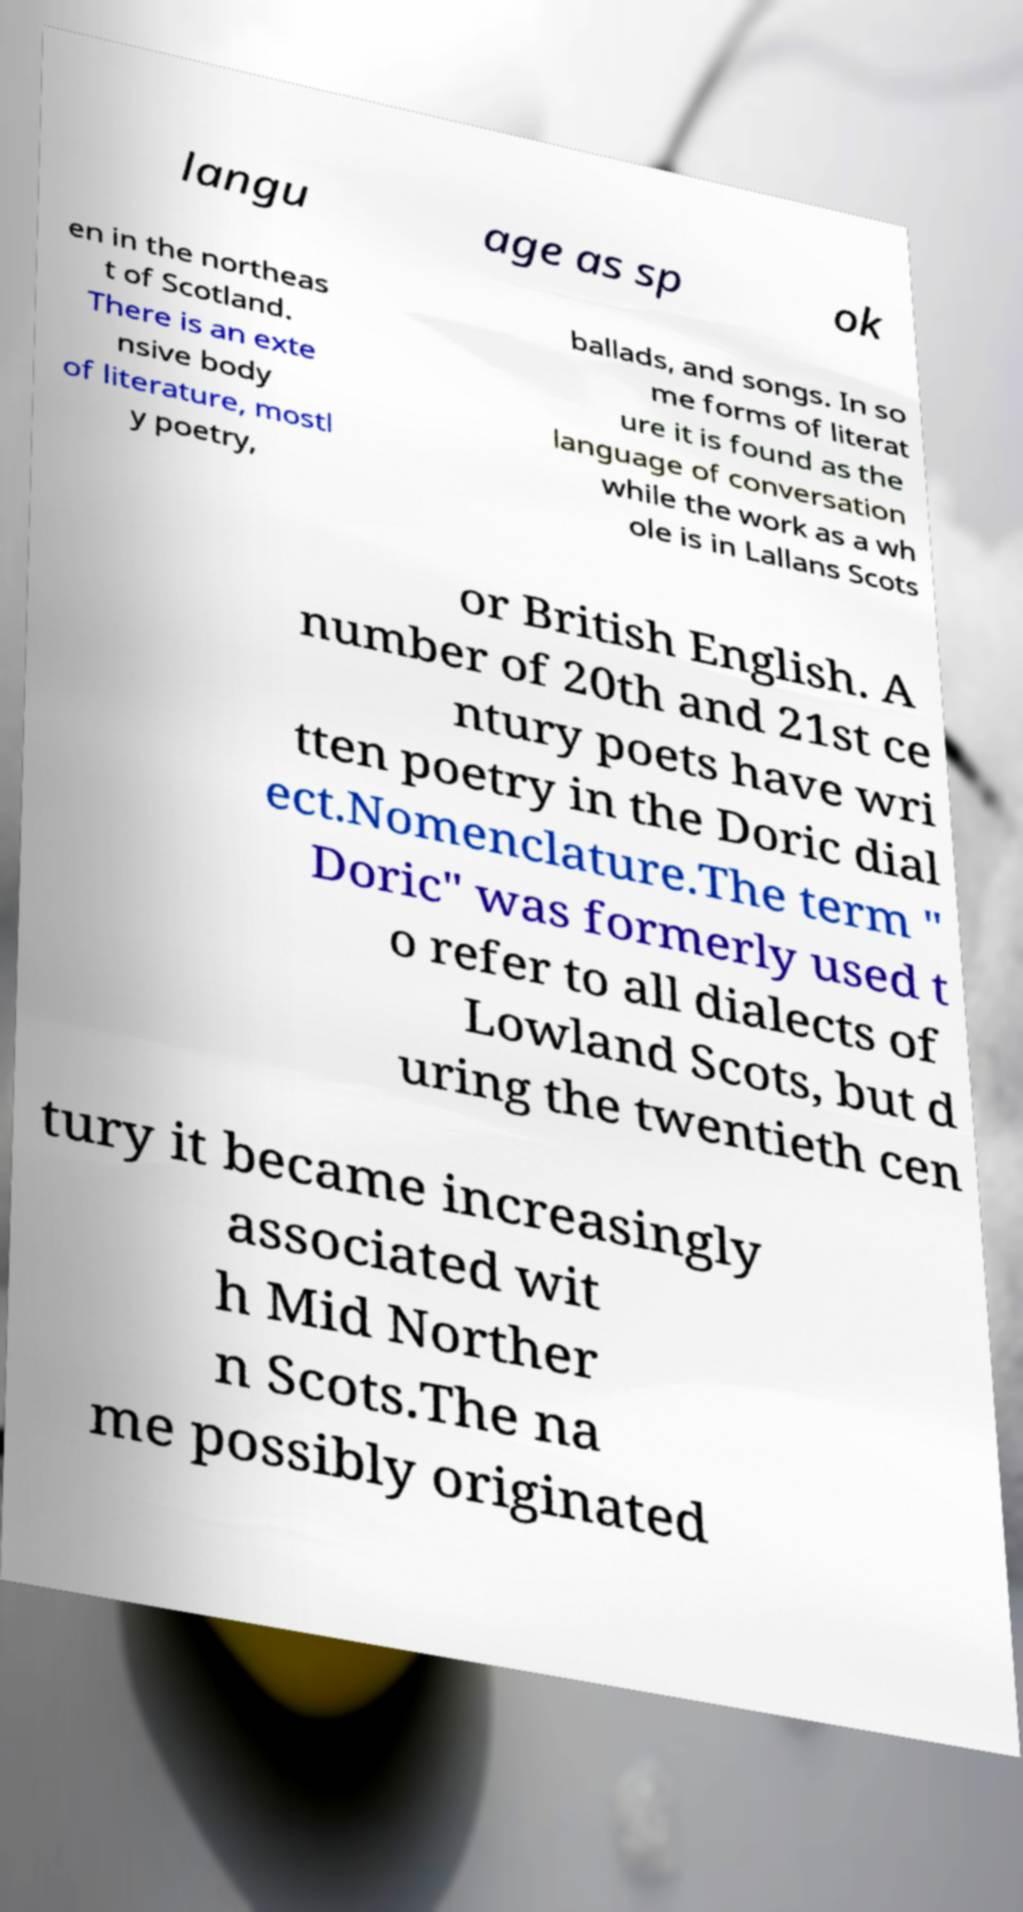Can you accurately transcribe the text from the provided image for me? langu age as sp ok en in the northeas t of Scotland. There is an exte nsive body of literature, mostl y poetry, ballads, and songs. In so me forms of literat ure it is found as the language of conversation while the work as a wh ole is in Lallans Scots or British English. A number of 20th and 21st ce ntury poets have wri tten poetry in the Doric dial ect.Nomenclature.The term " Doric" was formerly used t o refer to all dialects of Lowland Scots, but d uring the twentieth cen tury it became increasingly associated wit h Mid Norther n Scots.The na me possibly originated 